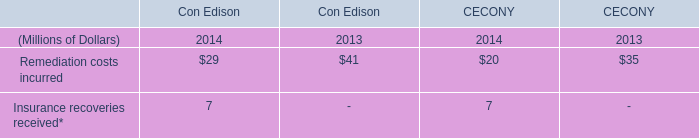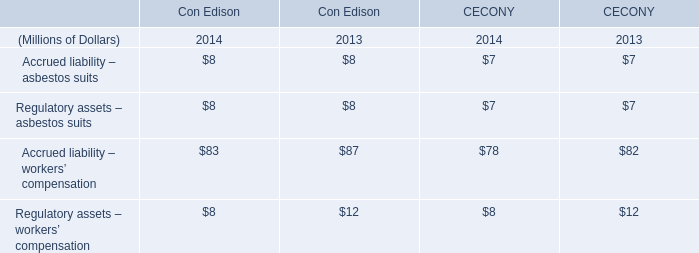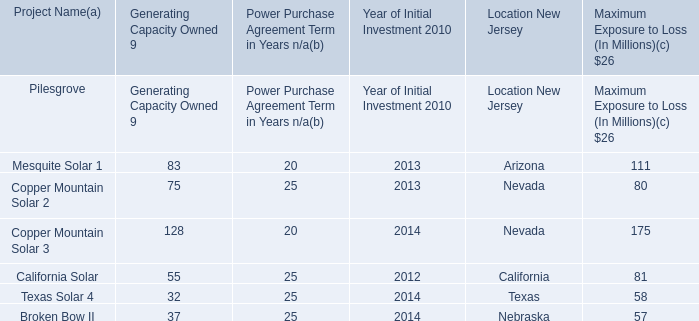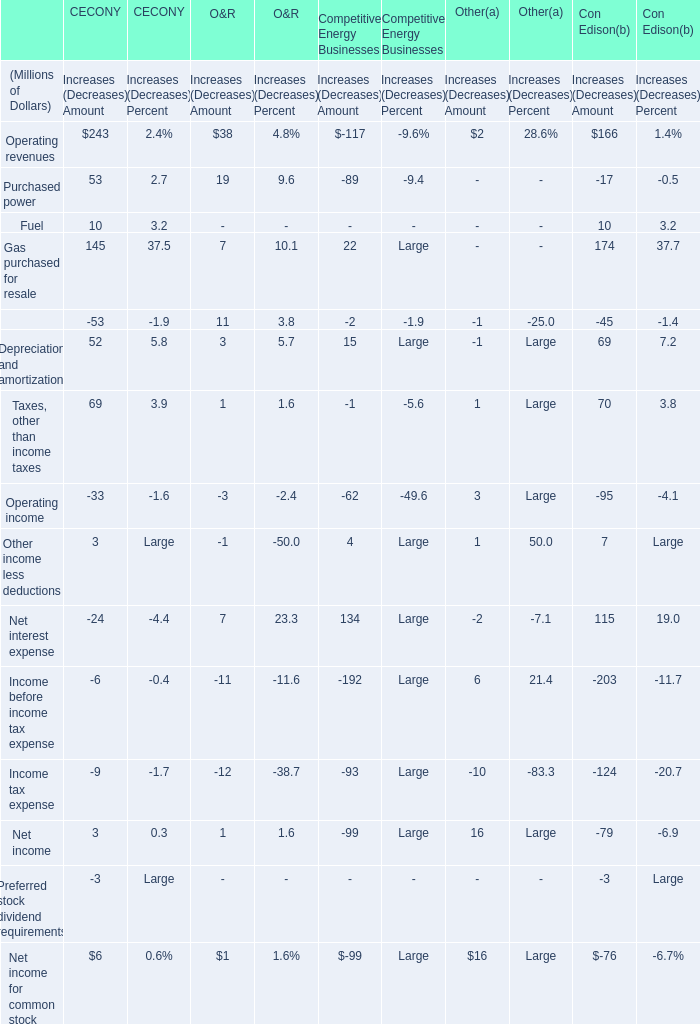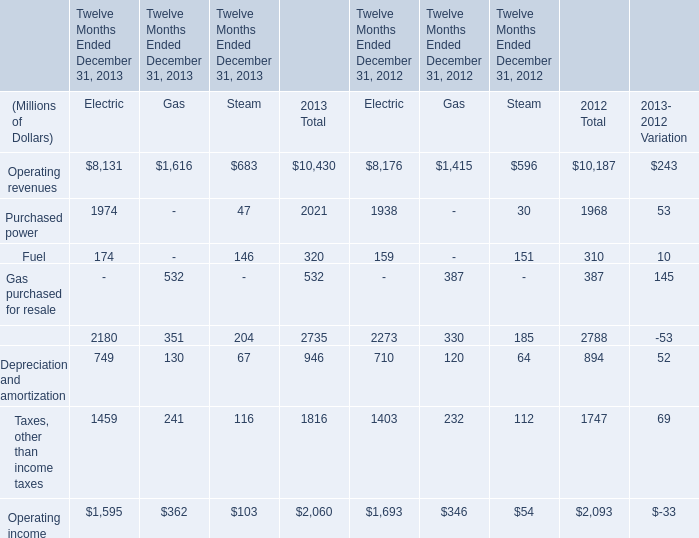What was the total amount of Increases (Decreases) Amount in terms of CECONY for Operating revenues? (in Millions) 
Answer: 243. 